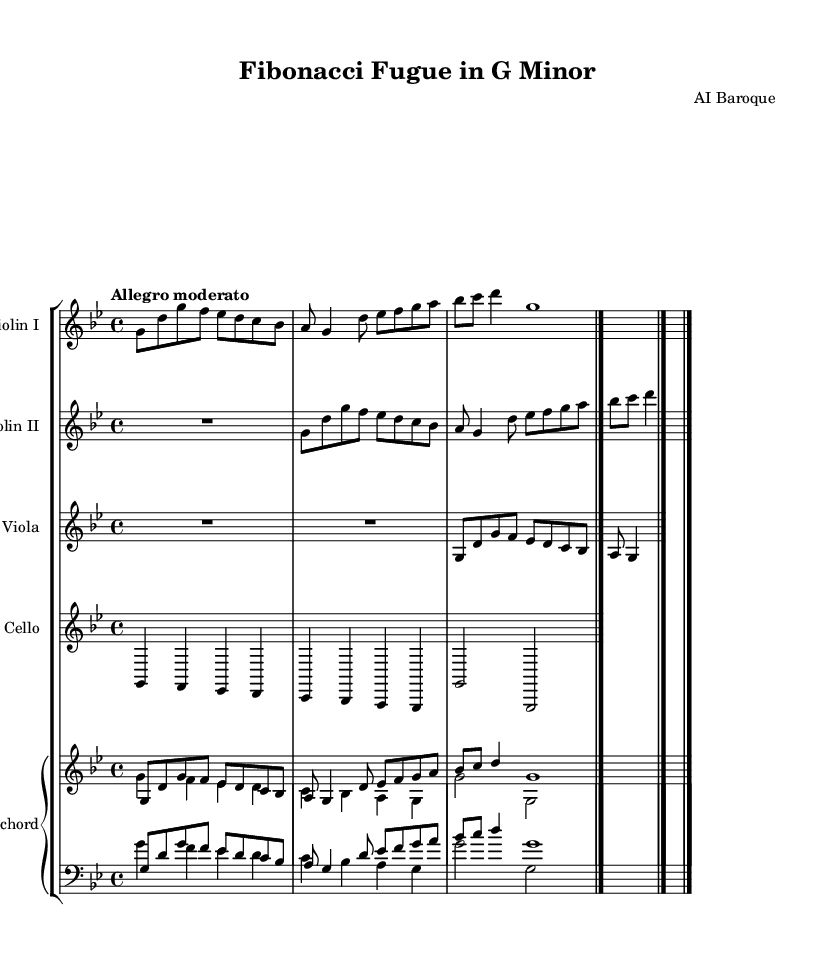What is the title of this piece? The title is found in the header section of the sheet music, which states "Fibonacci Fugue in G Minor."
Answer: Fibonacci Fugue in G Minor What is the key signature of this music? The key signature is indicated at the beginning of the score, which shows two flats, corresponding to the key of G minor.
Answer: G minor What is the time signature of this piece? The time signature is noted in the global section, showing a "4/4" time, meaning there are four beats in a measure.
Answer: 4/4 What is the tempo marking for this piece? The tempo marking is specified in the global section as "Allegro moderato," indicating a moderately fast pace.
Answer: Allegro moderato How many instruments are featured in this piece? By counting the different staves in the score group, we see there are five distinct instruments: Violin I, Violin II, Viola, Cello, and Harpsichord.
Answer: Five What is the structure of the violin parts in relation to the fugue form? The violin parts are structured to feature imitative counterpoint, where the second violin echoes the first at intervals, illustrating the fugue technique central to Baroque music.
Answer: Imitative counterpoint What mathematical sequence is represented in the melody? The melody incorporates the Fibonacci sequence through the rhythmic placement and note progression, connecting music composition with mathematical patterns in a fascinating way.
Answer: Fibonacci sequence 